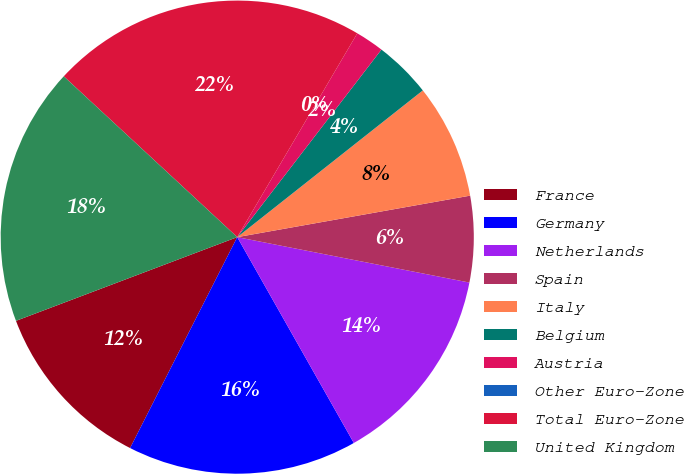Convert chart to OTSL. <chart><loc_0><loc_0><loc_500><loc_500><pie_chart><fcel>France<fcel>Germany<fcel>Netherlands<fcel>Spain<fcel>Italy<fcel>Belgium<fcel>Austria<fcel>Other Euro-Zone<fcel>Total Euro-Zone<fcel>United Kingdom<nl><fcel>11.76%<fcel>15.68%<fcel>13.72%<fcel>5.88%<fcel>7.84%<fcel>3.92%<fcel>1.96%<fcel>0.0%<fcel>21.57%<fcel>17.65%<nl></chart> 